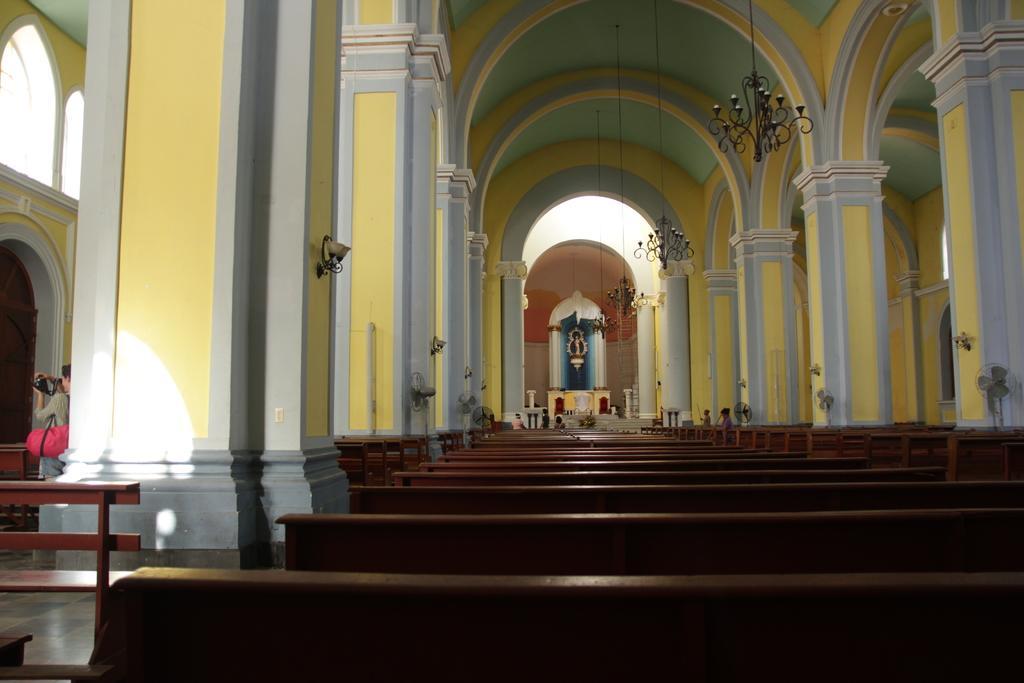How would you summarize this image in a sentence or two? There is a church. There are benches. A person is present at the left. There are table fans at the right. There are pillars and chandeliers on the top. 